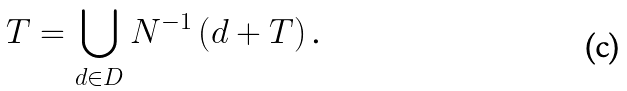Convert formula to latex. <formula><loc_0><loc_0><loc_500><loc_500>T = \bigcup _ { d \in D } N ^ { - 1 } \left ( d + T \right ) \text {.}</formula> 